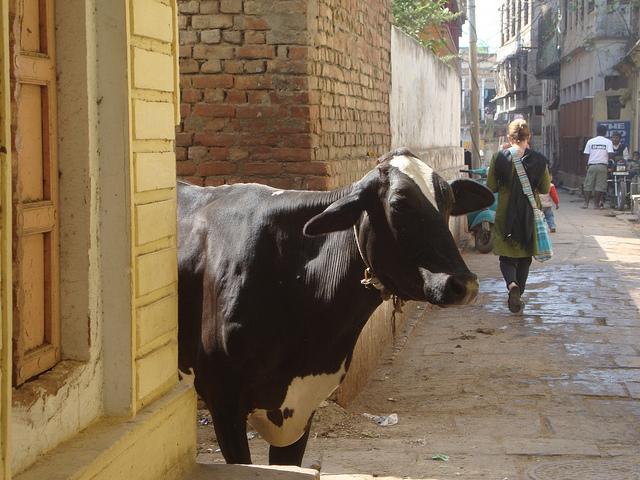What is peeking around the corner?
Concise answer only. Cow. Are there any people in this image?
Be succinct. Yes. Could two of this animal come through the doorway together?
Short answer required. No. Can the cow graze here?
Keep it brief. No. 